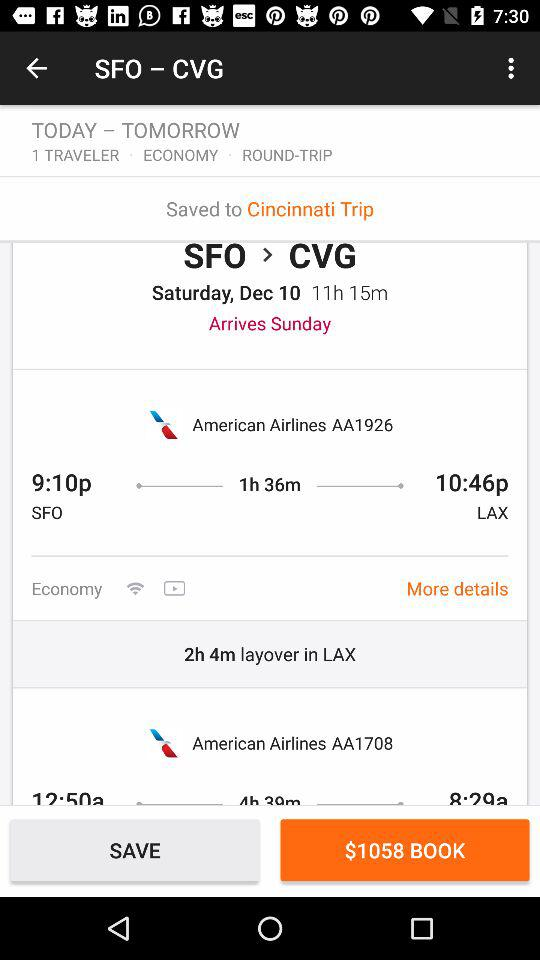What is the name of the airline? The name of the airline is "American Airlines". 